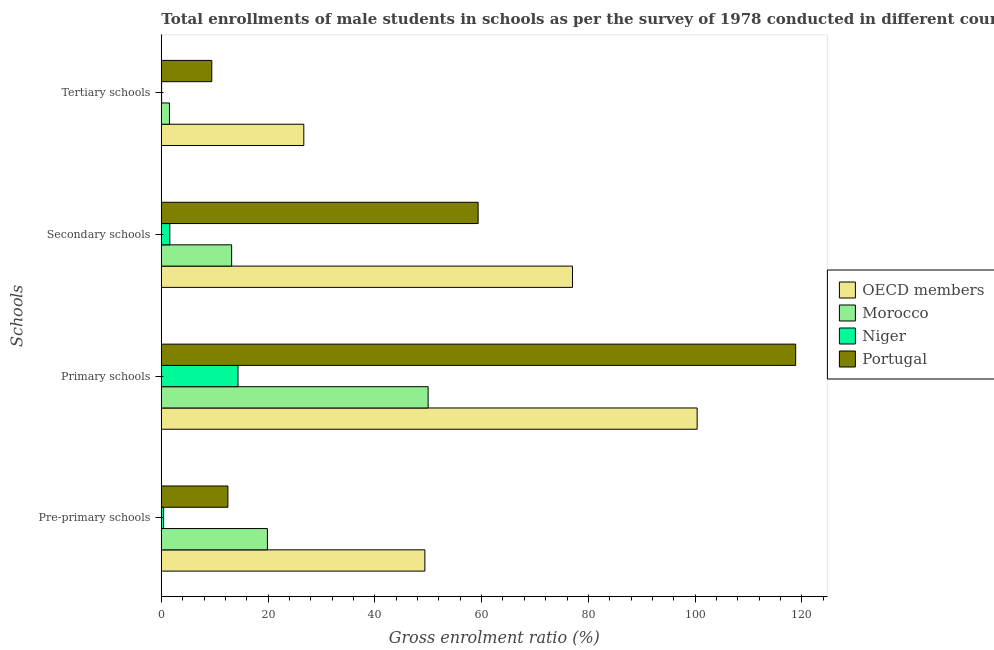Are the number of bars per tick equal to the number of legend labels?
Your answer should be very brief. Yes. Are the number of bars on each tick of the Y-axis equal?
Ensure brevity in your answer.  Yes. How many bars are there on the 1st tick from the top?
Your answer should be very brief. 4. How many bars are there on the 1st tick from the bottom?
Your answer should be very brief. 4. What is the label of the 3rd group of bars from the top?
Offer a very short reply. Primary schools. What is the gross enrolment ratio(male) in primary schools in OECD members?
Keep it short and to the point. 100.38. Across all countries, what is the maximum gross enrolment ratio(male) in tertiary schools?
Your answer should be compact. 26.69. Across all countries, what is the minimum gross enrolment ratio(male) in primary schools?
Offer a very short reply. 14.37. In which country was the gross enrolment ratio(male) in pre-primary schools maximum?
Provide a short and direct response. OECD members. In which country was the gross enrolment ratio(male) in tertiary schools minimum?
Ensure brevity in your answer.  Niger. What is the total gross enrolment ratio(male) in pre-primary schools in the graph?
Offer a very short reply. 82.15. What is the difference between the gross enrolment ratio(male) in tertiary schools in Niger and that in Morocco?
Your answer should be very brief. -1.47. What is the difference between the gross enrolment ratio(male) in secondary schools in Morocco and the gross enrolment ratio(male) in tertiary schools in OECD members?
Keep it short and to the point. -13.52. What is the average gross enrolment ratio(male) in secondary schools per country?
Your answer should be very brief. 37.78. What is the difference between the gross enrolment ratio(male) in pre-primary schools and gross enrolment ratio(male) in tertiary schools in Portugal?
Keep it short and to the point. 3.02. What is the ratio of the gross enrolment ratio(male) in primary schools in Morocco to that in Portugal?
Keep it short and to the point. 0.42. Is the difference between the gross enrolment ratio(male) in secondary schools in Niger and OECD members greater than the difference between the gross enrolment ratio(male) in primary schools in Niger and OECD members?
Keep it short and to the point. Yes. What is the difference between the highest and the second highest gross enrolment ratio(male) in secondary schools?
Your answer should be compact. 17.67. What is the difference between the highest and the lowest gross enrolment ratio(male) in secondary schools?
Offer a very short reply. 75.43. What does the 3rd bar from the top in Secondary schools represents?
Offer a terse response. Morocco. What does the 3rd bar from the bottom in Pre-primary schools represents?
Your response must be concise. Niger. What is the difference between two consecutive major ticks on the X-axis?
Give a very brief answer. 20. Does the graph contain any zero values?
Your answer should be very brief. No. Does the graph contain grids?
Keep it short and to the point. No. What is the title of the graph?
Make the answer very short. Total enrollments of male students in schools as per the survey of 1978 conducted in different countries. What is the label or title of the Y-axis?
Your answer should be compact. Schools. What is the Gross enrolment ratio (%) of OECD members in Pre-primary schools?
Ensure brevity in your answer.  49.37. What is the Gross enrolment ratio (%) of Morocco in Pre-primary schools?
Your answer should be compact. 19.88. What is the Gross enrolment ratio (%) in Niger in Pre-primary schools?
Provide a short and direct response. 0.43. What is the Gross enrolment ratio (%) of Portugal in Pre-primary schools?
Your answer should be very brief. 12.47. What is the Gross enrolment ratio (%) in OECD members in Primary schools?
Keep it short and to the point. 100.38. What is the Gross enrolment ratio (%) of Morocco in Primary schools?
Your answer should be compact. 49.98. What is the Gross enrolment ratio (%) in Niger in Primary schools?
Your answer should be compact. 14.37. What is the Gross enrolment ratio (%) of Portugal in Primary schools?
Your response must be concise. 118.83. What is the Gross enrolment ratio (%) in OECD members in Secondary schools?
Provide a succinct answer. 77.02. What is the Gross enrolment ratio (%) in Morocco in Secondary schools?
Your answer should be compact. 13.17. What is the Gross enrolment ratio (%) of Niger in Secondary schools?
Ensure brevity in your answer.  1.59. What is the Gross enrolment ratio (%) in Portugal in Secondary schools?
Your answer should be compact. 59.35. What is the Gross enrolment ratio (%) in OECD members in Tertiary schools?
Offer a terse response. 26.69. What is the Gross enrolment ratio (%) of Morocco in Tertiary schools?
Your answer should be compact. 1.53. What is the Gross enrolment ratio (%) of Niger in Tertiary schools?
Offer a terse response. 0.05. What is the Gross enrolment ratio (%) of Portugal in Tertiary schools?
Give a very brief answer. 9.46. Across all Schools, what is the maximum Gross enrolment ratio (%) in OECD members?
Keep it short and to the point. 100.38. Across all Schools, what is the maximum Gross enrolment ratio (%) of Morocco?
Your answer should be compact. 49.98. Across all Schools, what is the maximum Gross enrolment ratio (%) of Niger?
Your answer should be compact. 14.37. Across all Schools, what is the maximum Gross enrolment ratio (%) of Portugal?
Your response must be concise. 118.83. Across all Schools, what is the minimum Gross enrolment ratio (%) of OECD members?
Ensure brevity in your answer.  26.69. Across all Schools, what is the minimum Gross enrolment ratio (%) in Morocco?
Offer a terse response. 1.53. Across all Schools, what is the minimum Gross enrolment ratio (%) in Niger?
Provide a succinct answer. 0.05. Across all Schools, what is the minimum Gross enrolment ratio (%) in Portugal?
Provide a short and direct response. 9.46. What is the total Gross enrolment ratio (%) in OECD members in the graph?
Provide a short and direct response. 253.46. What is the total Gross enrolment ratio (%) in Morocco in the graph?
Ensure brevity in your answer.  84.56. What is the total Gross enrolment ratio (%) in Niger in the graph?
Your answer should be compact. 16.44. What is the total Gross enrolment ratio (%) in Portugal in the graph?
Make the answer very short. 200.11. What is the difference between the Gross enrolment ratio (%) of OECD members in Pre-primary schools and that in Primary schools?
Offer a very short reply. -51.01. What is the difference between the Gross enrolment ratio (%) in Morocco in Pre-primary schools and that in Primary schools?
Provide a short and direct response. -30.1. What is the difference between the Gross enrolment ratio (%) of Niger in Pre-primary schools and that in Primary schools?
Give a very brief answer. -13.94. What is the difference between the Gross enrolment ratio (%) of Portugal in Pre-primary schools and that in Primary schools?
Ensure brevity in your answer.  -106.36. What is the difference between the Gross enrolment ratio (%) in OECD members in Pre-primary schools and that in Secondary schools?
Offer a terse response. -27.65. What is the difference between the Gross enrolment ratio (%) of Morocco in Pre-primary schools and that in Secondary schools?
Ensure brevity in your answer.  6.71. What is the difference between the Gross enrolment ratio (%) in Niger in Pre-primary schools and that in Secondary schools?
Ensure brevity in your answer.  -1.17. What is the difference between the Gross enrolment ratio (%) in Portugal in Pre-primary schools and that in Secondary schools?
Make the answer very short. -46.88. What is the difference between the Gross enrolment ratio (%) in OECD members in Pre-primary schools and that in Tertiary schools?
Make the answer very short. 22.68. What is the difference between the Gross enrolment ratio (%) in Morocco in Pre-primary schools and that in Tertiary schools?
Make the answer very short. 18.35. What is the difference between the Gross enrolment ratio (%) of Niger in Pre-primary schools and that in Tertiary schools?
Provide a short and direct response. 0.37. What is the difference between the Gross enrolment ratio (%) of Portugal in Pre-primary schools and that in Tertiary schools?
Provide a succinct answer. 3.02. What is the difference between the Gross enrolment ratio (%) of OECD members in Primary schools and that in Secondary schools?
Make the answer very short. 23.36. What is the difference between the Gross enrolment ratio (%) in Morocco in Primary schools and that in Secondary schools?
Offer a terse response. 36.81. What is the difference between the Gross enrolment ratio (%) in Niger in Primary schools and that in Secondary schools?
Ensure brevity in your answer.  12.77. What is the difference between the Gross enrolment ratio (%) of Portugal in Primary schools and that in Secondary schools?
Offer a terse response. 59.48. What is the difference between the Gross enrolment ratio (%) of OECD members in Primary schools and that in Tertiary schools?
Your response must be concise. 73.68. What is the difference between the Gross enrolment ratio (%) in Morocco in Primary schools and that in Tertiary schools?
Keep it short and to the point. 48.45. What is the difference between the Gross enrolment ratio (%) in Niger in Primary schools and that in Tertiary schools?
Provide a succinct answer. 14.31. What is the difference between the Gross enrolment ratio (%) in Portugal in Primary schools and that in Tertiary schools?
Provide a succinct answer. 109.38. What is the difference between the Gross enrolment ratio (%) in OECD members in Secondary schools and that in Tertiary schools?
Give a very brief answer. 50.33. What is the difference between the Gross enrolment ratio (%) of Morocco in Secondary schools and that in Tertiary schools?
Offer a terse response. 11.65. What is the difference between the Gross enrolment ratio (%) of Niger in Secondary schools and that in Tertiary schools?
Offer a very short reply. 1.54. What is the difference between the Gross enrolment ratio (%) of Portugal in Secondary schools and that in Tertiary schools?
Provide a short and direct response. 49.89. What is the difference between the Gross enrolment ratio (%) in OECD members in Pre-primary schools and the Gross enrolment ratio (%) in Morocco in Primary schools?
Offer a terse response. -0.61. What is the difference between the Gross enrolment ratio (%) of OECD members in Pre-primary schools and the Gross enrolment ratio (%) of Niger in Primary schools?
Make the answer very short. 35. What is the difference between the Gross enrolment ratio (%) in OECD members in Pre-primary schools and the Gross enrolment ratio (%) in Portugal in Primary schools?
Give a very brief answer. -69.46. What is the difference between the Gross enrolment ratio (%) in Morocco in Pre-primary schools and the Gross enrolment ratio (%) in Niger in Primary schools?
Provide a short and direct response. 5.51. What is the difference between the Gross enrolment ratio (%) of Morocco in Pre-primary schools and the Gross enrolment ratio (%) of Portugal in Primary schools?
Keep it short and to the point. -98.96. What is the difference between the Gross enrolment ratio (%) of Niger in Pre-primary schools and the Gross enrolment ratio (%) of Portugal in Primary schools?
Your response must be concise. -118.41. What is the difference between the Gross enrolment ratio (%) in OECD members in Pre-primary schools and the Gross enrolment ratio (%) in Morocco in Secondary schools?
Give a very brief answer. 36.2. What is the difference between the Gross enrolment ratio (%) in OECD members in Pre-primary schools and the Gross enrolment ratio (%) in Niger in Secondary schools?
Offer a terse response. 47.78. What is the difference between the Gross enrolment ratio (%) in OECD members in Pre-primary schools and the Gross enrolment ratio (%) in Portugal in Secondary schools?
Ensure brevity in your answer.  -9.98. What is the difference between the Gross enrolment ratio (%) of Morocco in Pre-primary schools and the Gross enrolment ratio (%) of Niger in Secondary schools?
Your answer should be compact. 18.28. What is the difference between the Gross enrolment ratio (%) of Morocco in Pre-primary schools and the Gross enrolment ratio (%) of Portugal in Secondary schools?
Make the answer very short. -39.47. What is the difference between the Gross enrolment ratio (%) of Niger in Pre-primary schools and the Gross enrolment ratio (%) of Portugal in Secondary schools?
Your answer should be compact. -58.92. What is the difference between the Gross enrolment ratio (%) in OECD members in Pre-primary schools and the Gross enrolment ratio (%) in Morocco in Tertiary schools?
Give a very brief answer. 47.84. What is the difference between the Gross enrolment ratio (%) of OECD members in Pre-primary schools and the Gross enrolment ratio (%) of Niger in Tertiary schools?
Offer a terse response. 49.31. What is the difference between the Gross enrolment ratio (%) of OECD members in Pre-primary schools and the Gross enrolment ratio (%) of Portugal in Tertiary schools?
Your answer should be compact. 39.91. What is the difference between the Gross enrolment ratio (%) in Morocco in Pre-primary schools and the Gross enrolment ratio (%) in Niger in Tertiary schools?
Your response must be concise. 19.82. What is the difference between the Gross enrolment ratio (%) of Morocco in Pre-primary schools and the Gross enrolment ratio (%) of Portugal in Tertiary schools?
Ensure brevity in your answer.  10.42. What is the difference between the Gross enrolment ratio (%) of Niger in Pre-primary schools and the Gross enrolment ratio (%) of Portugal in Tertiary schools?
Offer a terse response. -9.03. What is the difference between the Gross enrolment ratio (%) of OECD members in Primary schools and the Gross enrolment ratio (%) of Morocco in Secondary schools?
Make the answer very short. 87.2. What is the difference between the Gross enrolment ratio (%) of OECD members in Primary schools and the Gross enrolment ratio (%) of Niger in Secondary schools?
Provide a short and direct response. 98.78. What is the difference between the Gross enrolment ratio (%) in OECD members in Primary schools and the Gross enrolment ratio (%) in Portugal in Secondary schools?
Your response must be concise. 41.03. What is the difference between the Gross enrolment ratio (%) of Morocco in Primary schools and the Gross enrolment ratio (%) of Niger in Secondary schools?
Offer a terse response. 48.39. What is the difference between the Gross enrolment ratio (%) in Morocco in Primary schools and the Gross enrolment ratio (%) in Portugal in Secondary schools?
Provide a short and direct response. -9.37. What is the difference between the Gross enrolment ratio (%) of Niger in Primary schools and the Gross enrolment ratio (%) of Portugal in Secondary schools?
Your answer should be very brief. -44.98. What is the difference between the Gross enrolment ratio (%) in OECD members in Primary schools and the Gross enrolment ratio (%) in Morocco in Tertiary schools?
Provide a short and direct response. 98.85. What is the difference between the Gross enrolment ratio (%) in OECD members in Primary schools and the Gross enrolment ratio (%) in Niger in Tertiary schools?
Offer a very short reply. 100.32. What is the difference between the Gross enrolment ratio (%) of OECD members in Primary schools and the Gross enrolment ratio (%) of Portugal in Tertiary schools?
Provide a short and direct response. 90.92. What is the difference between the Gross enrolment ratio (%) of Morocco in Primary schools and the Gross enrolment ratio (%) of Niger in Tertiary schools?
Provide a short and direct response. 49.93. What is the difference between the Gross enrolment ratio (%) of Morocco in Primary schools and the Gross enrolment ratio (%) of Portugal in Tertiary schools?
Provide a short and direct response. 40.53. What is the difference between the Gross enrolment ratio (%) of Niger in Primary schools and the Gross enrolment ratio (%) of Portugal in Tertiary schools?
Offer a very short reply. 4.91. What is the difference between the Gross enrolment ratio (%) in OECD members in Secondary schools and the Gross enrolment ratio (%) in Morocco in Tertiary schools?
Give a very brief answer. 75.49. What is the difference between the Gross enrolment ratio (%) of OECD members in Secondary schools and the Gross enrolment ratio (%) of Niger in Tertiary schools?
Ensure brevity in your answer.  76.97. What is the difference between the Gross enrolment ratio (%) in OECD members in Secondary schools and the Gross enrolment ratio (%) in Portugal in Tertiary schools?
Provide a short and direct response. 67.57. What is the difference between the Gross enrolment ratio (%) of Morocco in Secondary schools and the Gross enrolment ratio (%) of Niger in Tertiary schools?
Keep it short and to the point. 13.12. What is the difference between the Gross enrolment ratio (%) in Morocco in Secondary schools and the Gross enrolment ratio (%) in Portugal in Tertiary schools?
Offer a terse response. 3.72. What is the difference between the Gross enrolment ratio (%) in Niger in Secondary schools and the Gross enrolment ratio (%) in Portugal in Tertiary schools?
Your answer should be very brief. -7.86. What is the average Gross enrolment ratio (%) of OECD members per Schools?
Provide a short and direct response. 63.37. What is the average Gross enrolment ratio (%) in Morocco per Schools?
Provide a succinct answer. 21.14. What is the average Gross enrolment ratio (%) in Niger per Schools?
Your response must be concise. 4.11. What is the average Gross enrolment ratio (%) in Portugal per Schools?
Your answer should be compact. 50.03. What is the difference between the Gross enrolment ratio (%) of OECD members and Gross enrolment ratio (%) of Morocco in Pre-primary schools?
Your answer should be very brief. 29.49. What is the difference between the Gross enrolment ratio (%) of OECD members and Gross enrolment ratio (%) of Niger in Pre-primary schools?
Your answer should be compact. 48.94. What is the difference between the Gross enrolment ratio (%) in OECD members and Gross enrolment ratio (%) in Portugal in Pre-primary schools?
Ensure brevity in your answer.  36.9. What is the difference between the Gross enrolment ratio (%) of Morocco and Gross enrolment ratio (%) of Niger in Pre-primary schools?
Offer a very short reply. 19.45. What is the difference between the Gross enrolment ratio (%) of Morocco and Gross enrolment ratio (%) of Portugal in Pre-primary schools?
Your answer should be compact. 7.4. What is the difference between the Gross enrolment ratio (%) in Niger and Gross enrolment ratio (%) in Portugal in Pre-primary schools?
Provide a succinct answer. -12.05. What is the difference between the Gross enrolment ratio (%) in OECD members and Gross enrolment ratio (%) in Morocco in Primary schools?
Keep it short and to the point. 50.39. What is the difference between the Gross enrolment ratio (%) of OECD members and Gross enrolment ratio (%) of Niger in Primary schools?
Provide a succinct answer. 86.01. What is the difference between the Gross enrolment ratio (%) in OECD members and Gross enrolment ratio (%) in Portugal in Primary schools?
Make the answer very short. -18.46. What is the difference between the Gross enrolment ratio (%) in Morocco and Gross enrolment ratio (%) in Niger in Primary schools?
Offer a very short reply. 35.61. What is the difference between the Gross enrolment ratio (%) in Morocco and Gross enrolment ratio (%) in Portugal in Primary schools?
Keep it short and to the point. -68.85. What is the difference between the Gross enrolment ratio (%) in Niger and Gross enrolment ratio (%) in Portugal in Primary schools?
Give a very brief answer. -104.47. What is the difference between the Gross enrolment ratio (%) in OECD members and Gross enrolment ratio (%) in Morocco in Secondary schools?
Give a very brief answer. 63.85. What is the difference between the Gross enrolment ratio (%) in OECD members and Gross enrolment ratio (%) in Niger in Secondary schools?
Your answer should be compact. 75.43. What is the difference between the Gross enrolment ratio (%) in OECD members and Gross enrolment ratio (%) in Portugal in Secondary schools?
Ensure brevity in your answer.  17.67. What is the difference between the Gross enrolment ratio (%) in Morocco and Gross enrolment ratio (%) in Niger in Secondary schools?
Offer a terse response. 11.58. What is the difference between the Gross enrolment ratio (%) in Morocco and Gross enrolment ratio (%) in Portugal in Secondary schools?
Your answer should be compact. -46.18. What is the difference between the Gross enrolment ratio (%) in Niger and Gross enrolment ratio (%) in Portugal in Secondary schools?
Provide a short and direct response. -57.76. What is the difference between the Gross enrolment ratio (%) of OECD members and Gross enrolment ratio (%) of Morocco in Tertiary schools?
Offer a terse response. 25.17. What is the difference between the Gross enrolment ratio (%) of OECD members and Gross enrolment ratio (%) of Niger in Tertiary schools?
Your response must be concise. 26.64. What is the difference between the Gross enrolment ratio (%) of OECD members and Gross enrolment ratio (%) of Portugal in Tertiary schools?
Keep it short and to the point. 17.24. What is the difference between the Gross enrolment ratio (%) in Morocco and Gross enrolment ratio (%) in Niger in Tertiary schools?
Keep it short and to the point. 1.47. What is the difference between the Gross enrolment ratio (%) in Morocco and Gross enrolment ratio (%) in Portugal in Tertiary schools?
Provide a succinct answer. -7.93. What is the difference between the Gross enrolment ratio (%) of Niger and Gross enrolment ratio (%) of Portugal in Tertiary schools?
Offer a terse response. -9.4. What is the ratio of the Gross enrolment ratio (%) in OECD members in Pre-primary schools to that in Primary schools?
Your answer should be compact. 0.49. What is the ratio of the Gross enrolment ratio (%) in Morocco in Pre-primary schools to that in Primary schools?
Keep it short and to the point. 0.4. What is the ratio of the Gross enrolment ratio (%) in Niger in Pre-primary schools to that in Primary schools?
Your answer should be compact. 0.03. What is the ratio of the Gross enrolment ratio (%) of Portugal in Pre-primary schools to that in Primary schools?
Offer a very short reply. 0.1. What is the ratio of the Gross enrolment ratio (%) of OECD members in Pre-primary schools to that in Secondary schools?
Provide a short and direct response. 0.64. What is the ratio of the Gross enrolment ratio (%) of Morocco in Pre-primary schools to that in Secondary schools?
Ensure brevity in your answer.  1.51. What is the ratio of the Gross enrolment ratio (%) of Niger in Pre-primary schools to that in Secondary schools?
Provide a succinct answer. 0.27. What is the ratio of the Gross enrolment ratio (%) of Portugal in Pre-primary schools to that in Secondary schools?
Keep it short and to the point. 0.21. What is the ratio of the Gross enrolment ratio (%) of OECD members in Pre-primary schools to that in Tertiary schools?
Provide a succinct answer. 1.85. What is the ratio of the Gross enrolment ratio (%) of Morocco in Pre-primary schools to that in Tertiary schools?
Keep it short and to the point. 13.01. What is the ratio of the Gross enrolment ratio (%) of Niger in Pre-primary schools to that in Tertiary schools?
Offer a very short reply. 7.76. What is the ratio of the Gross enrolment ratio (%) in Portugal in Pre-primary schools to that in Tertiary schools?
Your answer should be very brief. 1.32. What is the ratio of the Gross enrolment ratio (%) in OECD members in Primary schools to that in Secondary schools?
Keep it short and to the point. 1.3. What is the ratio of the Gross enrolment ratio (%) in Morocco in Primary schools to that in Secondary schools?
Keep it short and to the point. 3.79. What is the ratio of the Gross enrolment ratio (%) in Niger in Primary schools to that in Secondary schools?
Offer a terse response. 9.02. What is the ratio of the Gross enrolment ratio (%) of Portugal in Primary schools to that in Secondary schools?
Provide a short and direct response. 2. What is the ratio of the Gross enrolment ratio (%) of OECD members in Primary schools to that in Tertiary schools?
Make the answer very short. 3.76. What is the ratio of the Gross enrolment ratio (%) in Morocco in Primary schools to that in Tertiary schools?
Provide a short and direct response. 32.72. What is the ratio of the Gross enrolment ratio (%) of Niger in Primary schools to that in Tertiary schools?
Make the answer very short. 262.38. What is the ratio of the Gross enrolment ratio (%) of Portugal in Primary schools to that in Tertiary schools?
Offer a terse response. 12.57. What is the ratio of the Gross enrolment ratio (%) of OECD members in Secondary schools to that in Tertiary schools?
Give a very brief answer. 2.89. What is the ratio of the Gross enrolment ratio (%) of Morocco in Secondary schools to that in Tertiary schools?
Your response must be concise. 8.62. What is the ratio of the Gross enrolment ratio (%) in Niger in Secondary schools to that in Tertiary schools?
Offer a terse response. 29.1. What is the ratio of the Gross enrolment ratio (%) of Portugal in Secondary schools to that in Tertiary schools?
Ensure brevity in your answer.  6.28. What is the difference between the highest and the second highest Gross enrolment ratio (%) in OECD members?
Provide a succinct answer. 23.36. What is the difference between the highest and the second highest Gross enrolment ratio (%) of Morocco?
Offer a terse response. 30.1. What is the difference between the highest and the second highest Gross enrolment ratio (%) of Niger?
Provide a succinct answer. 12.77. What is the difference between the highest and the second highest Gross enrolment ratio (%) in Portugal?
Keep it short and to the point. 59.48. What is the difference between the highest and the lowest Gross enrolment ratio (%) of OECD members?
Keep it short and to the point. 73.68. What is the difference between the highest and the lowest Gross enrolment ratio (%) in Morocco?
Your answer should be very brief. 48.45. What is the difference between the highest and the lowest Gross enrolment ratio (%) in Niger?
Your answer should be compact. 14.31. What is the difference between the highest and the lowest Gross enrolment ratio (%) in Portugal?
Offer a terse response. 109.38. 